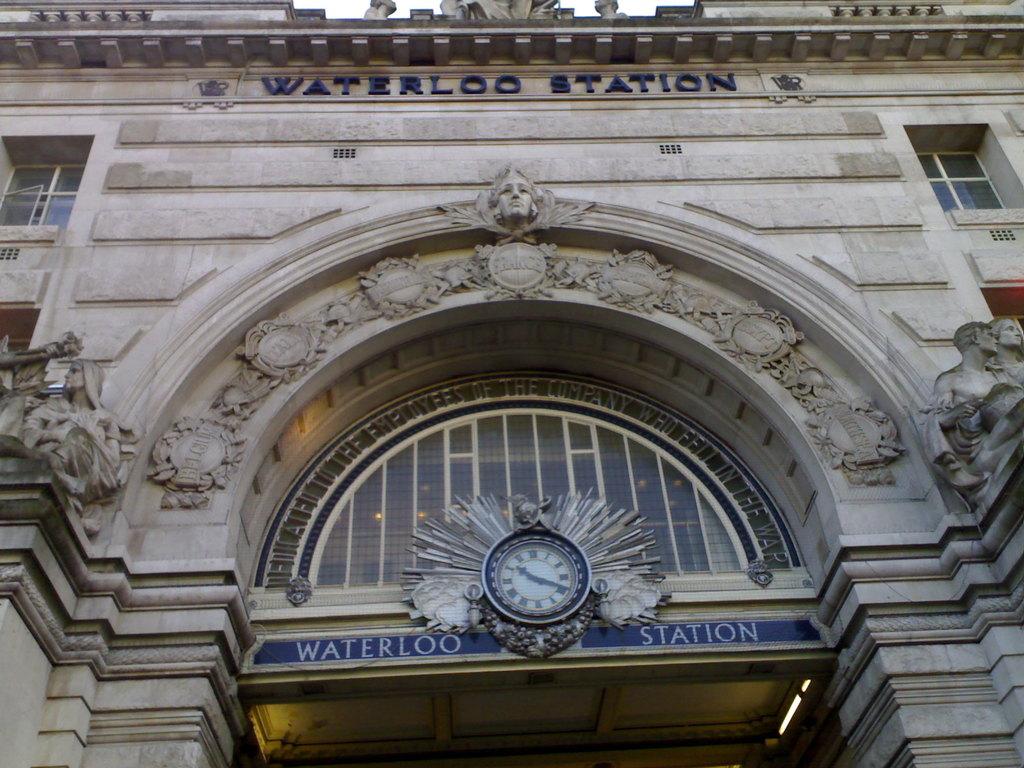What station is this?
Your response must be concise. Waterloo station. What time does the clock say?
Make the answer very short. 10:19. 